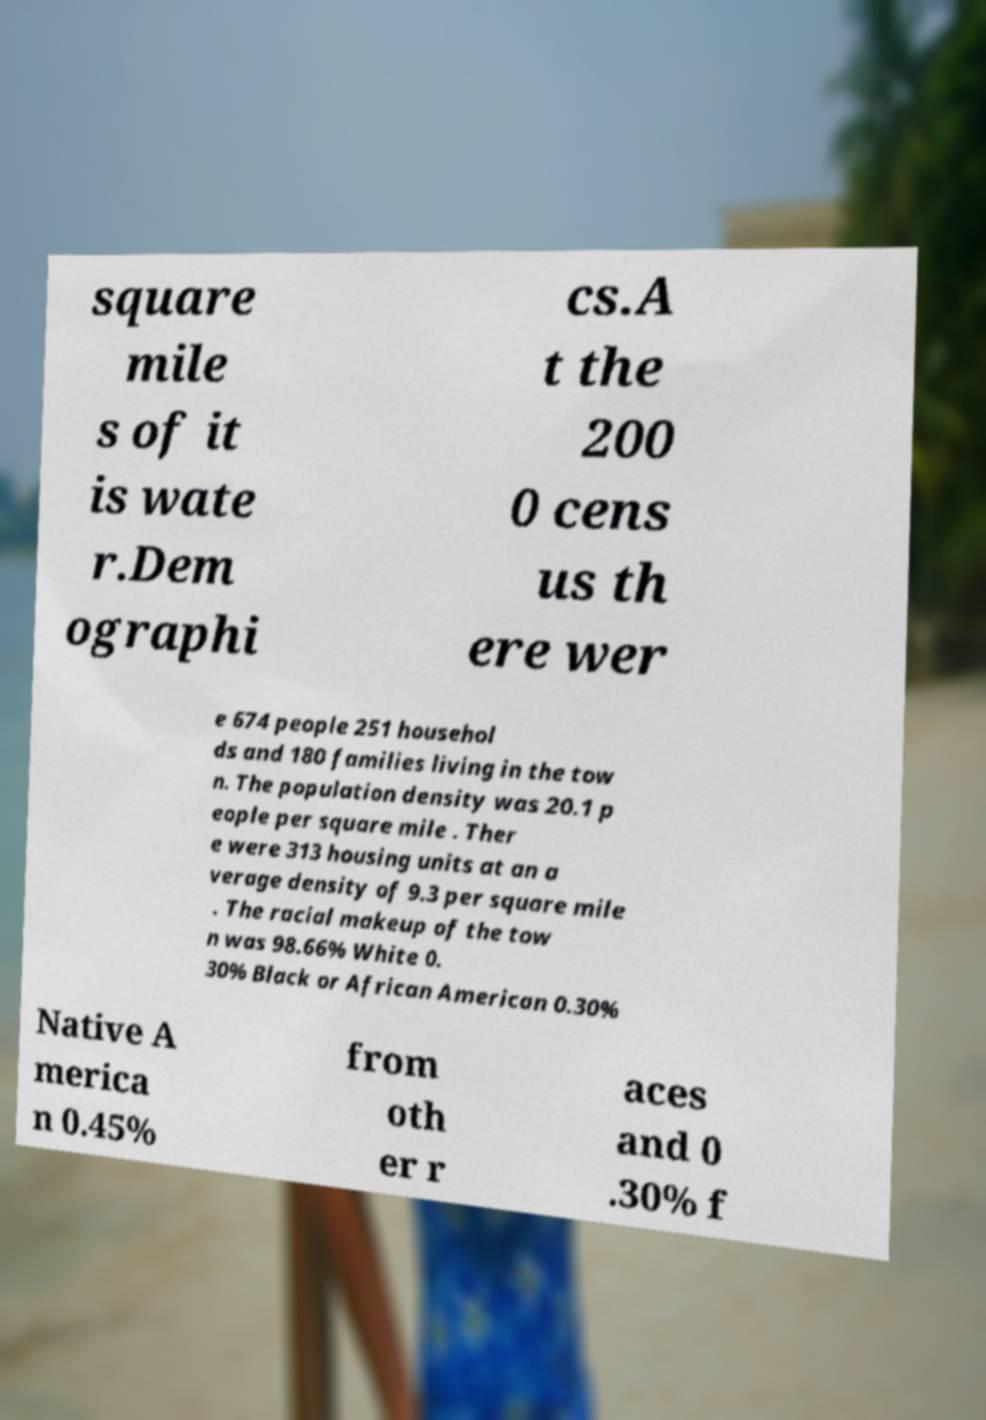What messages or text are displayed in this image? I need them in a readable, typed format. square mile s of it is wate r.Dem ographi cs.A t the 200 0 cens us th ere wer e 674 people 251 househol ds and 180 families living in the tow n. The population density was 20.1 p eople per square mile . Ther e were 313 housing units at an a verage density of 9.3 per square mile . The racial makeup of the tow n was 98.66% White 0. 30% Black or African American 0.30% Native A merica n 0.45% from oth er r aces and 0 .30% f 